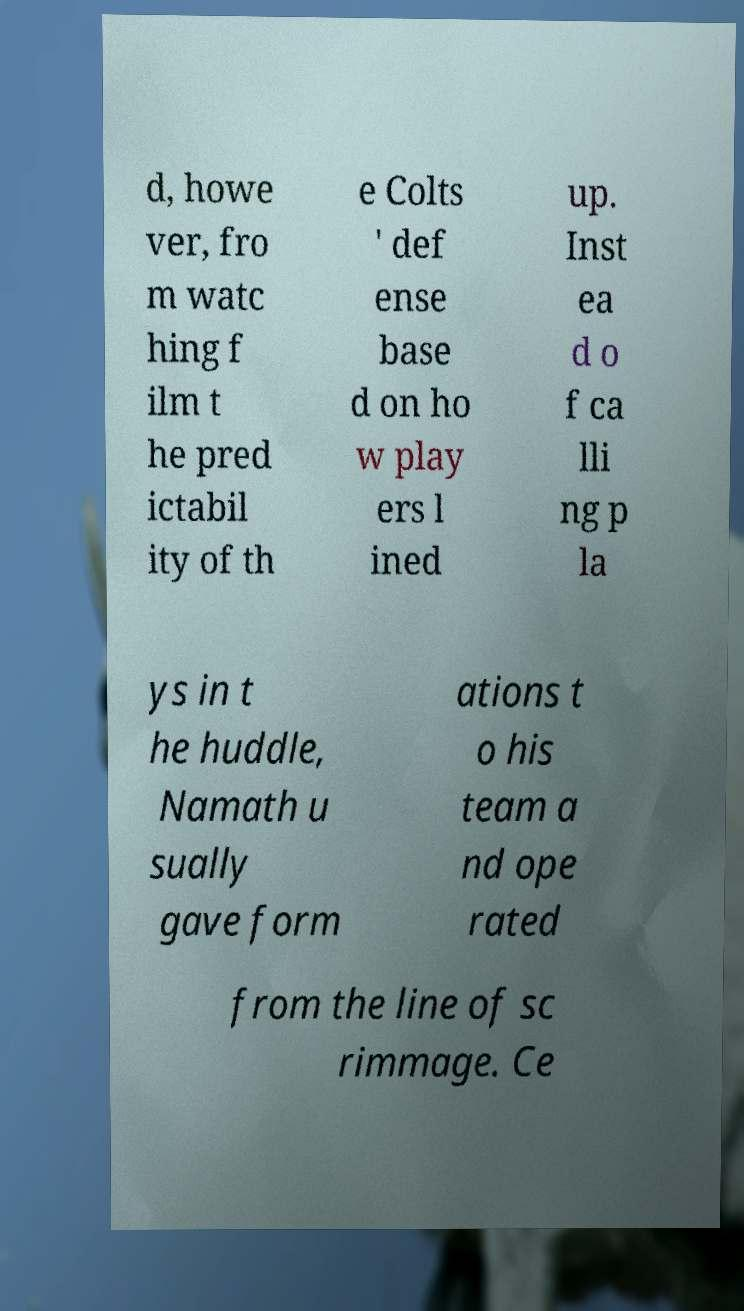Please identify and transcribe the text found in this image. d, howe ver, fro m watc hing f ilm t he pred ictabil ity of th e Colts ' def ense base d on ho w play ers l ined up. Inst ea d o f ca lli ng p la ys in t he huddle, Namath u sually gave form ations t o his team a nd ope rated from the line of sc rimmage. Ce 